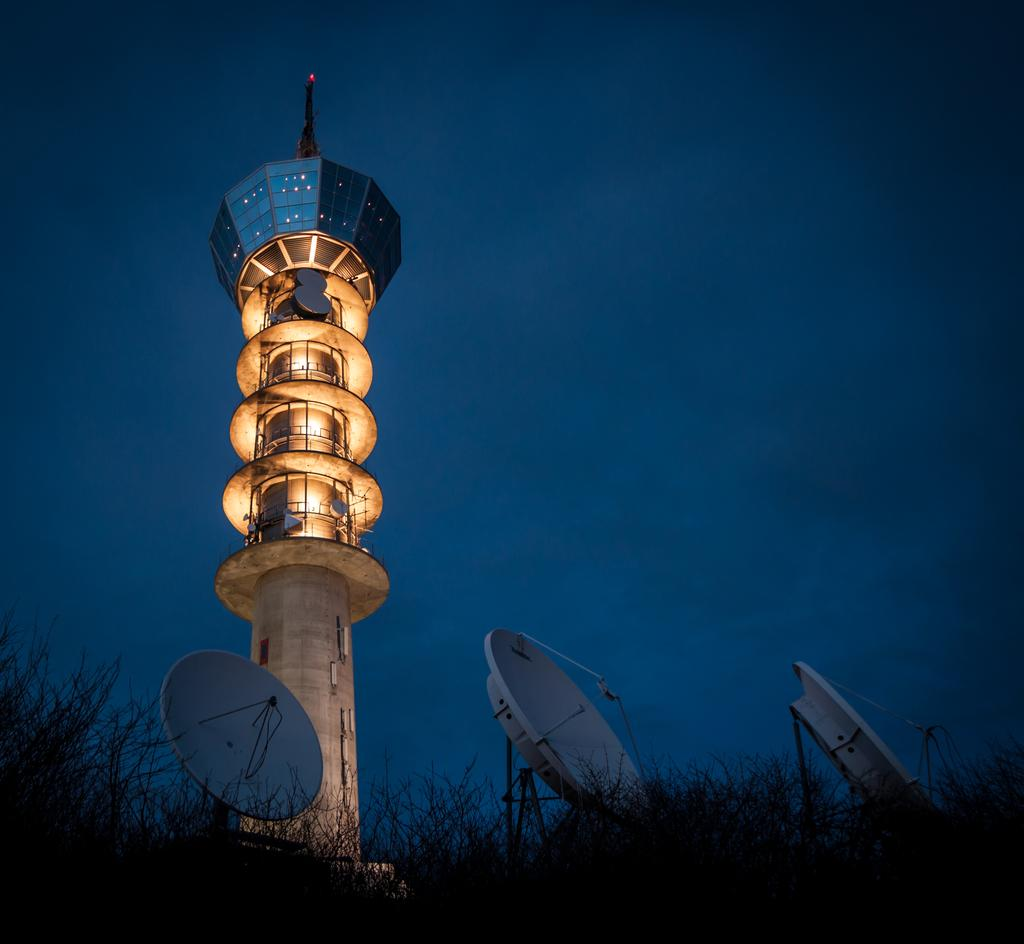What is the main structure in the image? There is a tower in the image. What can be seen on the tower? There are lights and dishes on the tower. What is present at the bottom of the image? There are dishes and plants at the bottom of the image. What is visible at the top of the image? The sky is visible at the top of the image. What type of poison is being used to water the plants at the bottom of the image? There is no poison present in the image; the plants are being watered with regular water. What is the temper of the tower in the image? The tower is an inanimate object and does not have a temper. 